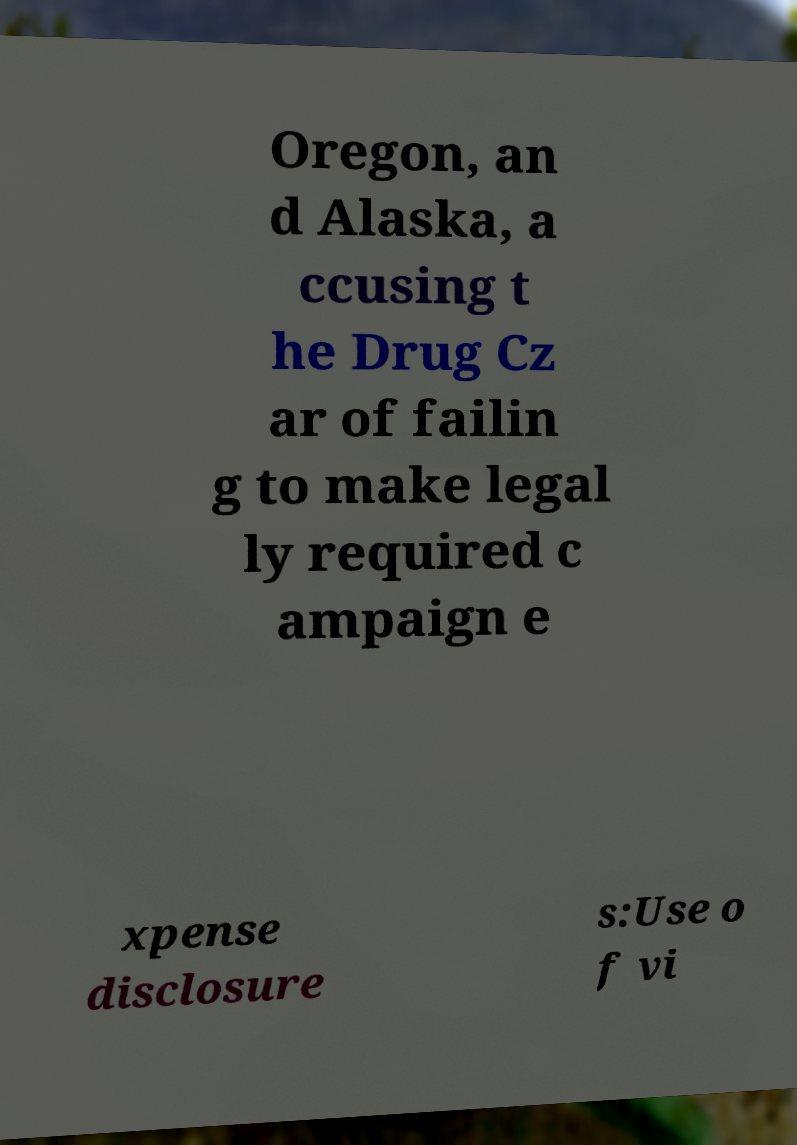What messages or text are displayed in this image? I need them in a readable, typed format. Oregon, an d Alaska, a ccusing t he Drug Cz ar of failin g to make legal ly required c ampaign e xpense disclosure s:Use o f vi 